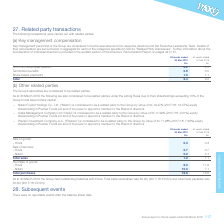According to Premier Foods Plc's financial document, What was the equity shareholding of Nissin Food Holdings Co., Ltd. in Premier Foods plc in 2019? According to the financial document, 19.47%. The relevant text states: "o be a related party to the Group by virtue of its 19.47% (2017/18: 19.57%) equity shareholding in Premier Foods plc and of its power to appoint a member to t..." Also, What was the total trade receivables in 2019? According to the financial document, £0.9m. The relevant text states: "g balances with Hovis. Total trade receivables was £0.9m (2017/18: £0.5m) and total trade payables was £0.6m (2017/18: £2.5m). 28. Subsequent events There we..." Also, What was the hovis sale of goods in 2019? According to the financial document, 0.3 (in millions). The relevant text states: "weeks ended 31 Mar 2018 £m Sale of goods: – Hovis 0.3 0.3 Sale of services: – Hovis 0.7 0.7 – Nissin 0.2 0.1..." Also, can you calculate: What was the change in hovis sale of goods from 2018 to 2019? I cannot find a specific answer to this question in the financial document. Also, can you calculate: What is the average hovis sale of services for 2018 and 2019? To answer this question, I need to perform calculations using the financial data. The calculation is: (0.7 + 0.7) / 2, which equals 0.7 (in millions). This is based on the information: "goods: – Hovis 0.3 0.3 Sale of services: – Hovis 0.7 0.7 – Nissin 0.2 0.1..." Also, can you calculate: What is the average hovis purchase of goods for 2018 and 2019? To answer this question, I need to perform calculations using the financial data. The calculation is: (6.3 + 11.9) / 2, which equals 9.1 (in millions). This is based on the information: "Total sales 1.2 1.1 Purchase of goods: – Hovis 6.3 11.9 – Nissin 10.3 7.1 otal sales 1.2 1.1 Purchase of goods: – Hovis 6.3 11.9 – Nissin 10.3 7.1..." The key data points involved are: 11.9, 6.3. 